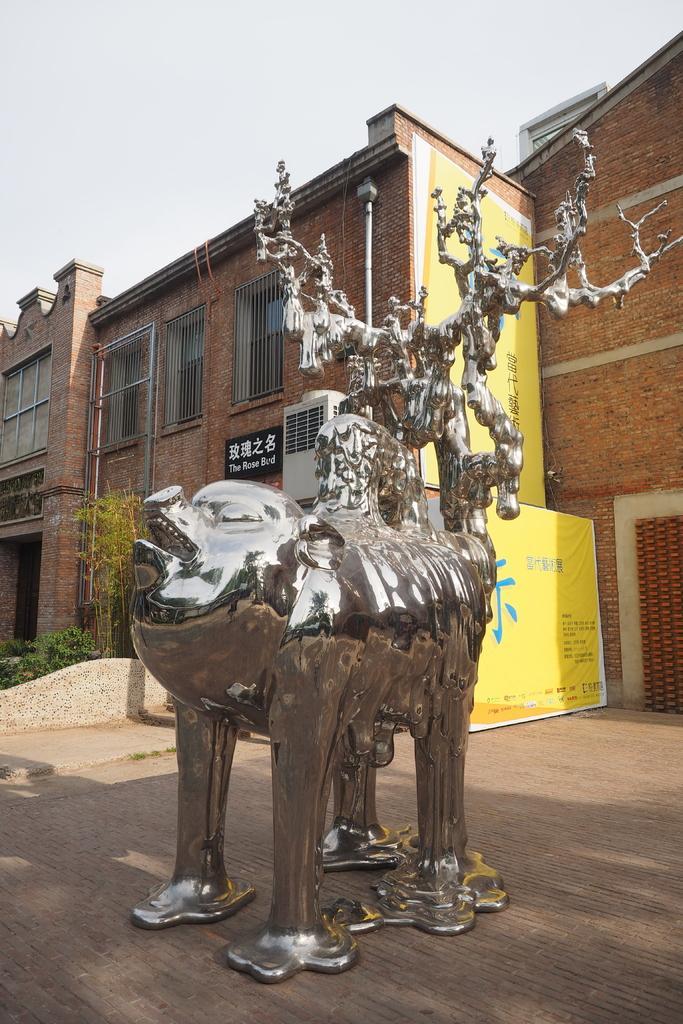In one or two sentences, can you explain what this image depicts? In this image in the middle there is a metal statue. In the background there are buildings, plants. The sky is clear. 